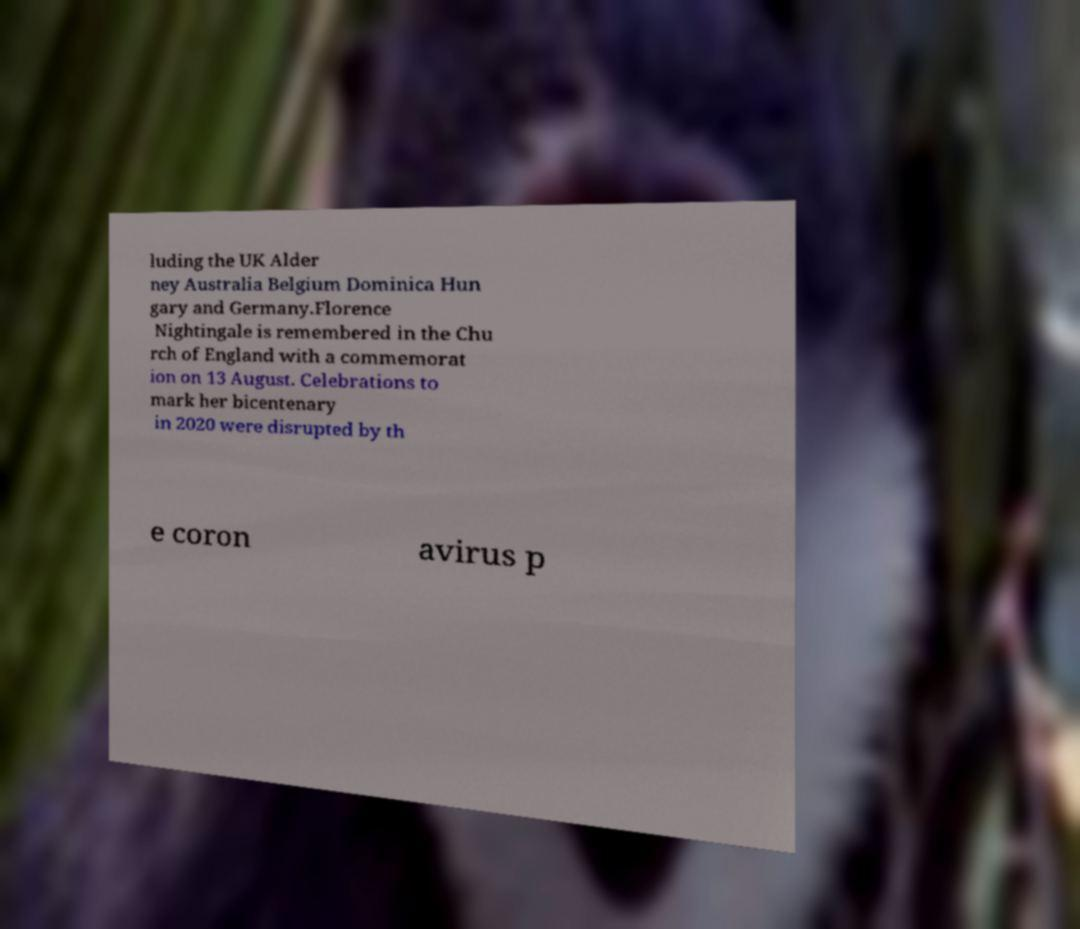Please read and relay the text visible in this image. What does it say? luding the UK Alder ney Australia Belgium Dominica Hun gary and Germany.Florence Nightingale is remembered in the Chu rch of England with a commemorat ion on 13 August. Celebrations to mark her bicentenary in 2020 were disrupted by th e coron avirus p 